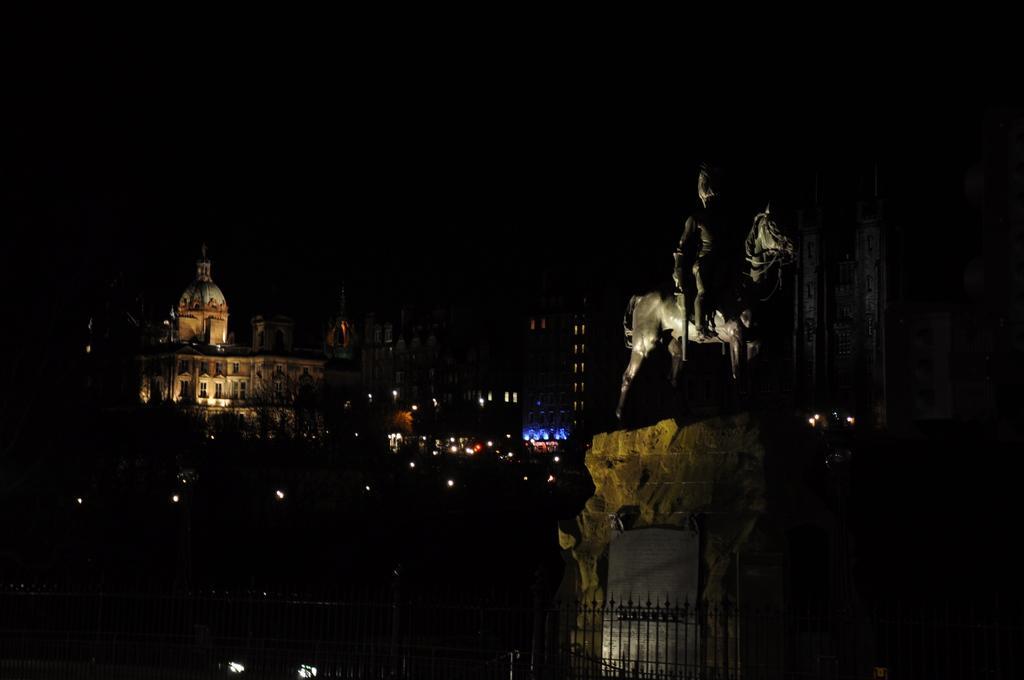Describe this image in one or two sentences. This is the statue of a person sitting on the horse. This statue is placed on the rock. I think this is an iron grill. I can see the buildings with windows and lights. The background looks dark. 